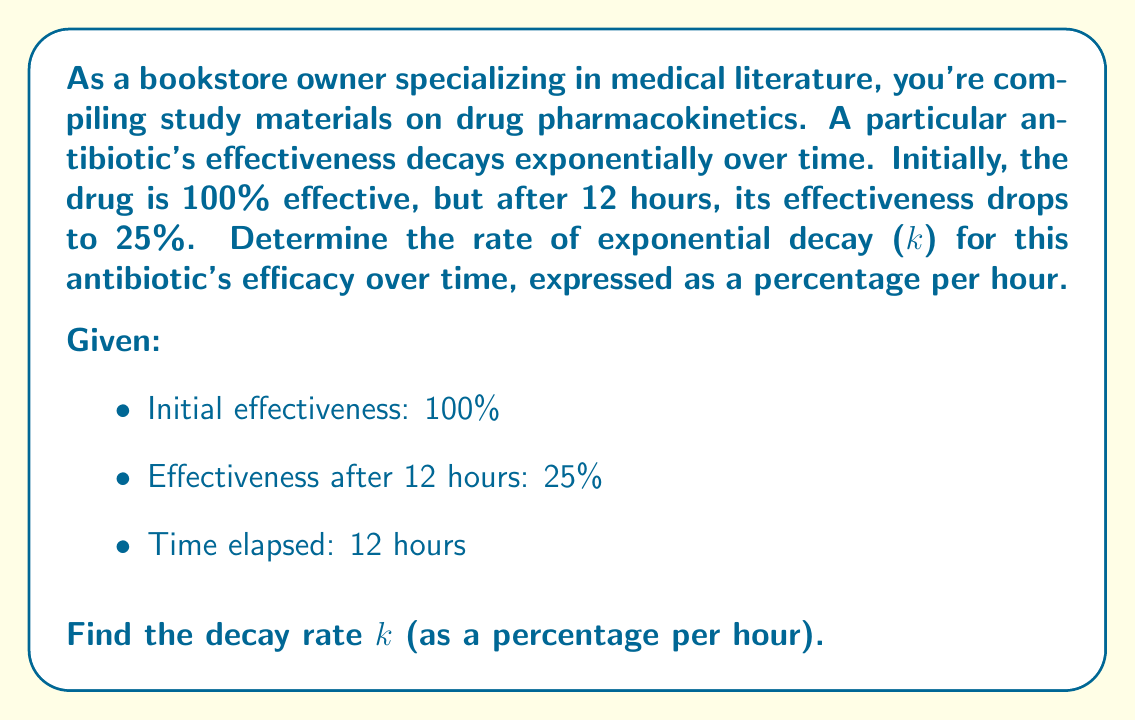Provide a solution to this math problem. To solve this problem, we'll use the exponential decay formula:

$$ A(t) = A_0 e^{-kt} $$

Where:
$A(t)$ is the amount at time $t$
$A_0$ is the initial amount
$k$ is the decay rate
$t$ is the time elapsed

Let's plug in the known values:

$$ 25 = 100 e^{-k(12)} $$

Now, we'll solve for $k$:

1) Divide both sides by 100:
   $$ 0.25 = e^{-12k} $$

2) Take the natural log of both sides:
   $$ \ln(0.25) = -12k $$

3) Solve for $k$:
   $$ k = -\frac{\ln(0.25)}{12} $$

4) Calculate the value:
   $$ k = -\frac{\ln(0.25)}{12} \approx 0.1155 $$

5) Convert to percentage per hour:
   $$ k \approx 0.1155 \times 100\% = 11.55\% \text{ per hour} $$

Therefore, the rate of exponential decay for the antibiotic's efficacy is approximately 11.55% per hour.
Answer: The rate of exponential decay (k) for the antibiotic's efficacy is approximately 11.55% per hour. 